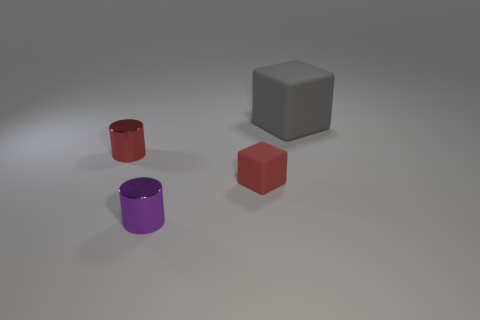There is a matte thing in front of the red metal object; is it the same color as the small metallic cylinder that is behind the red rubber object?
Provide a short and direct response. Yes. There is a object that is to the right of the small red rubber thing right of the small thing that is behind the tiny red matte object; what color is it?
Offer a terse response. Gray. There is a big gray matte thing behind the red matte object; are there any matte things that are in front of it?
Offer a terse response. Yes. There is a object to the left of the tiny purple cylinder; is it the same shape as the purple metal thing?
Provide a succinct answer. Yes. How many blocks are gray matte things or red objects?
Your answer should be compact. 2. What number of tiny objects are there?
Provide a short and direct response. 3. What size is the shiny object that is left of the shiny cylinder that is right of the tiny red metallic object?
Ensure brevity in your answer.  Small. How many other things are there of the same size as the gray rubber object?
Your answer should be compact. 0. What number of small red objects are left of the purple object?
Your answer should be very brief. 1. How big is the purple object?
Your answer should be very brief. Small. 